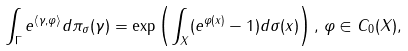Convert formula to latex. <formula><loc_0><loc_0><loc_500><loc_500>\int _ { \Gamma } e ^ { \langle \gamma , \varphi \rangle } d \pi _ { \sigma } ( \gamma ) = \exp \left ( \int _ { X } ( e ^ { \varphi ( x ) } - 1 ) d \sigma ( x ) \right ) , \, \varphi \in C _ { 0 } ( X ) ,</formula> 